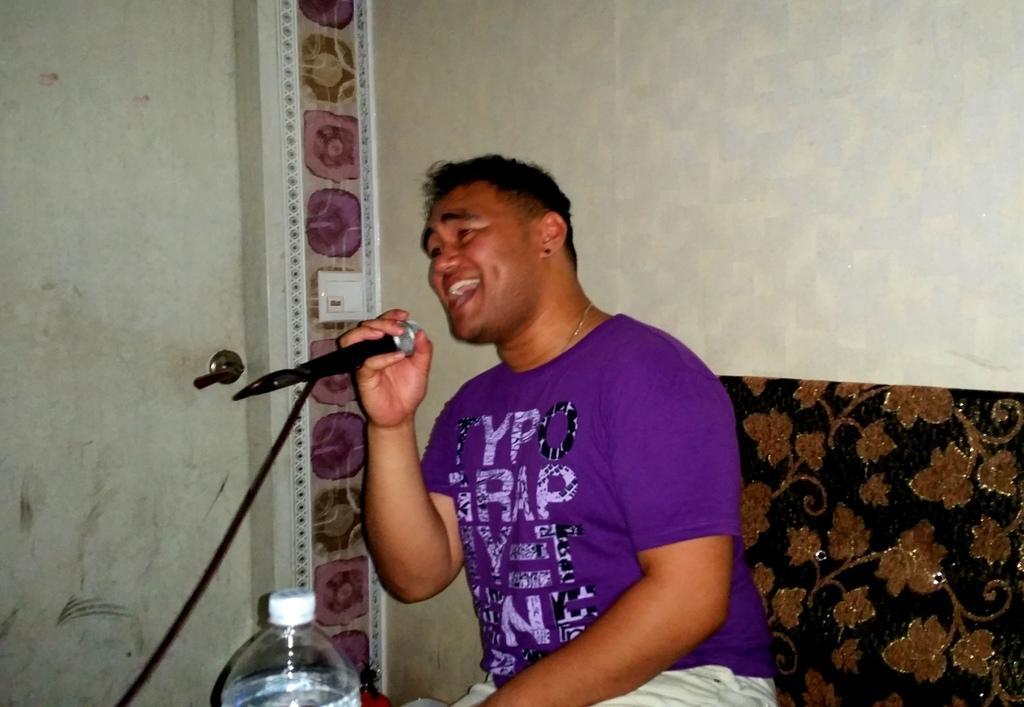Please provide a concise description of this image. The picture is taken in a closed room where a person is sitting on the sofa wearing purple t-shirt and singing in the microphone in front of him, behind him there is a wall and door, in front of him there is a water bottle. 